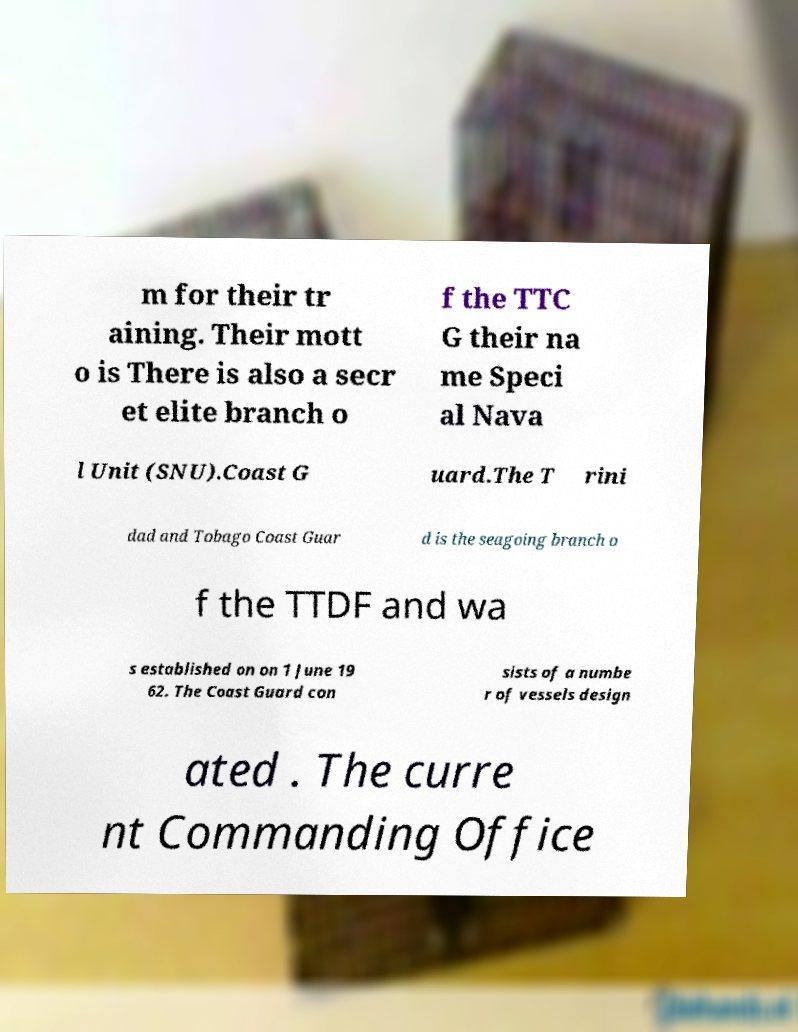Could you extract and type out the text from this image? m for their tr aining. Their mott o is There is also a secr et elite branch o f the TTC G their na me Speci al Nava l Unit (SNU).Coast G uard.The T rini dad and Tobago Coast Guar d is the seagoing branch o f the TTDF and wa s established on on 1 June 19 62. The Coast Guard con sists of a numbe r of vessels design ated . The curre nt Commanding Office 